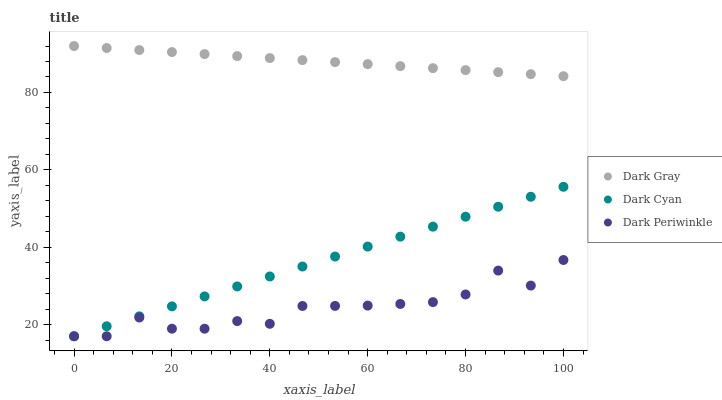Does Dark Periwinkle have the minimum area under the curve?
Answer yes or no. Yes. Does Dark Gray have the maximum area under the curve?
Answer yes or no. Yes. Does Dark Cyan have the minimum area under the curve?
Answer yes or no. No. Does Dark Cyan have the maximum area under the curve?
Answer yes or no. No. Is Dark Cyan the smoothest?
Answer yes or no. Yes. Is Dark Periwinkle the roughest?
Answer yes or no. Yes. Is Dark Periwinkle the smoothest?
Answer yes or no. No. Is Dark Cyan the roughest?
Answer yes or no. No. Does Dark Cyan have the lowest value?
Answer yes or no. Yes. Does Dark Gray have the highest value?
Answer yes or no. Yes. Does Dark Cyan have the highest value?
Answer yes or no. No. Is Dark Periwinkle less than Dark Gray?
Answer yes or no. Yes. Is Dark Gray greater than Dark Cyan?
Answer yes or no. Yes. Does Dark Cyan intersect Dark Periwinkle?
Answer yes or no. Yes. Is Dark Cyan less than Dark Periwinkle?
Answer yes or no. No. Is Dark Cyan greater than Dark Periwinkle?
Answer yes or no. No. Does Dark Periwinkle intersect Dark Gray?
Answer yes or no. No. 